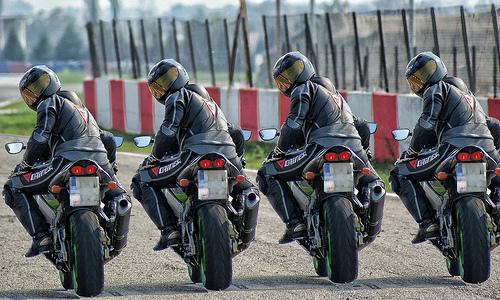Question: what are they doing?
Choices:
A. Flying kites.
B. Riding bikes.
C. Playing marbles.
D. Shooting dice.
Answer with the letter. Answer: B Question: who are they?
Choices:
A. Bike riders.
B. Gamblers.
C. Boys.
D. Football team.
Answer with the letter. Answer: A Question: how many are they?
Choices:
A. 5.
B. 4.
C. 6.
D. 7.
Answer with the letter. Answer: B Question: why are they looking behind?
Choices:
A. Watching a kite.
B. Looking at an accident.
C. Watching Fly Ball.
D. Looking at the camera.
Answer with the letter. Answer: D Question: what do they have?
Choices:
A. Bikes.
B. Gloves.
C. Helmets.
D. Bats.
Answer with the letter. Answer: A Question: what are they wearing?
Choices:
A. Hats.
B. Helmets.
C. Scarves.
D. Watches.
Answer with the letter. Answer: B 